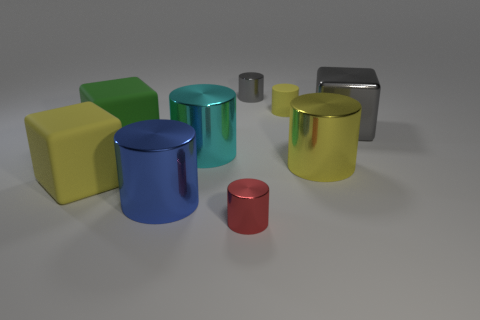Subtract all blue cylinders. How many cylinders are left? 5 Subtract all red metallic cylinders. How many cylinders are left? 5 Subtract all gray cylinders. Subtract all yellow spheres. How many cylinders are left? 5 Add 1 large gray cubes. How many objects exist? 10 Subtract all cylinders. How many objects are left? 3 Subtract 0 blue blocks. How many objects are left? 9 Subtract all blue metallic cylinders. Subtract all large green matte cubes. How many objects are left? 7 Add 6 large gray shiny things. How many large gray shiny things are left? 7 Add 8 small yellow cylinders. How many small yellow cylinders exist? 9 